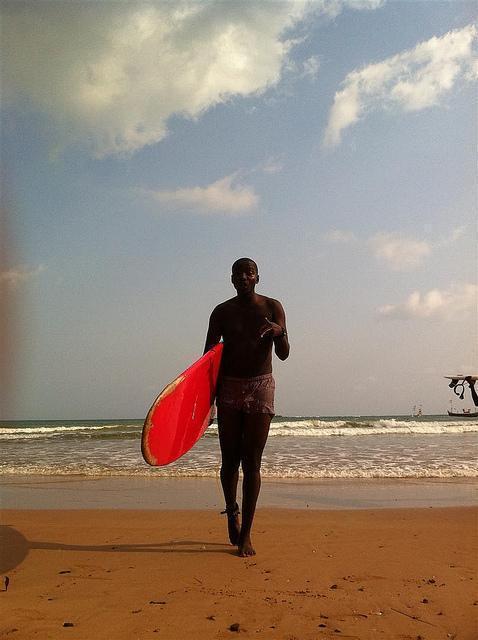What country is this most likely?
Select the correct answer and articulate reasoning with the following format: 'Answer: answer
Rationale: rationale.'
Options: China, ireland, jamaica, russia. Answer: jamaica.
Rationale: The country is jamaica. 